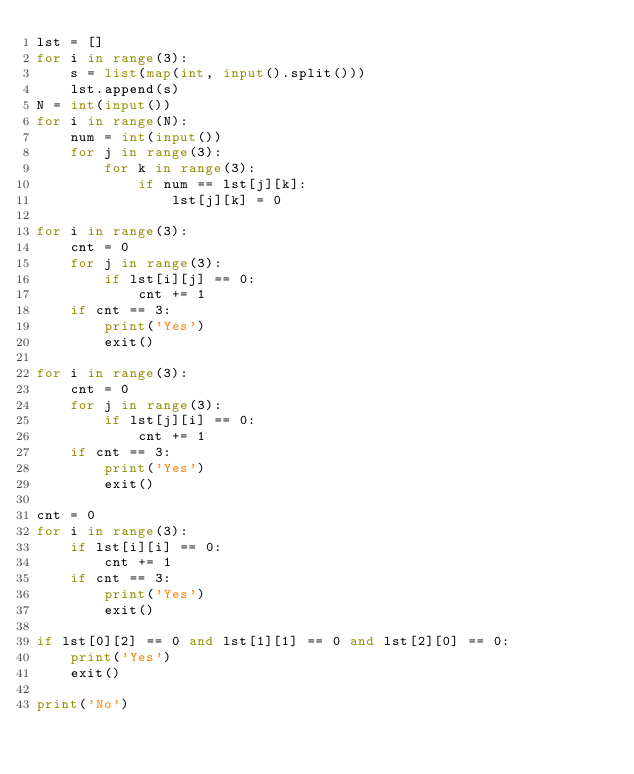Convert code to text. <code><loc_0><loc_0><loc_500><loc_500><_Python_>lst = []
for i in range(3):
    s = list(map(int, input().split()))
    lst.append(s)
N = int(input())
for i in range(N):
    num = int(input())
    for j in range(3):
        for k in range(3):
            if num == lst[j][k]:
                lst[j][k] = 0

for i in range(3):
    cnt = 0
    for j in range(3):
        if lst[i][j] == 0:
            cnt += 1
    if cnt == 3:
        print('Yes')
        exit()

for i in range(3):
    cnt = 0
    for j in range(3):
        if lst[j][i] == 0:
            cnt += 1
    if cnt == 3:
        print('Yes')
        exit()

cnt = 0
for i in range(3):
    if lst[i][i] == 0:
        cnt += 1
    if cnt == 3:
        print('Yes')
        exit()

if lst[0][2] == 0 and lst[1][1] == 0 and lst[2][0] == 0:
    print('Yes')
    exit()

print('No')</code> 